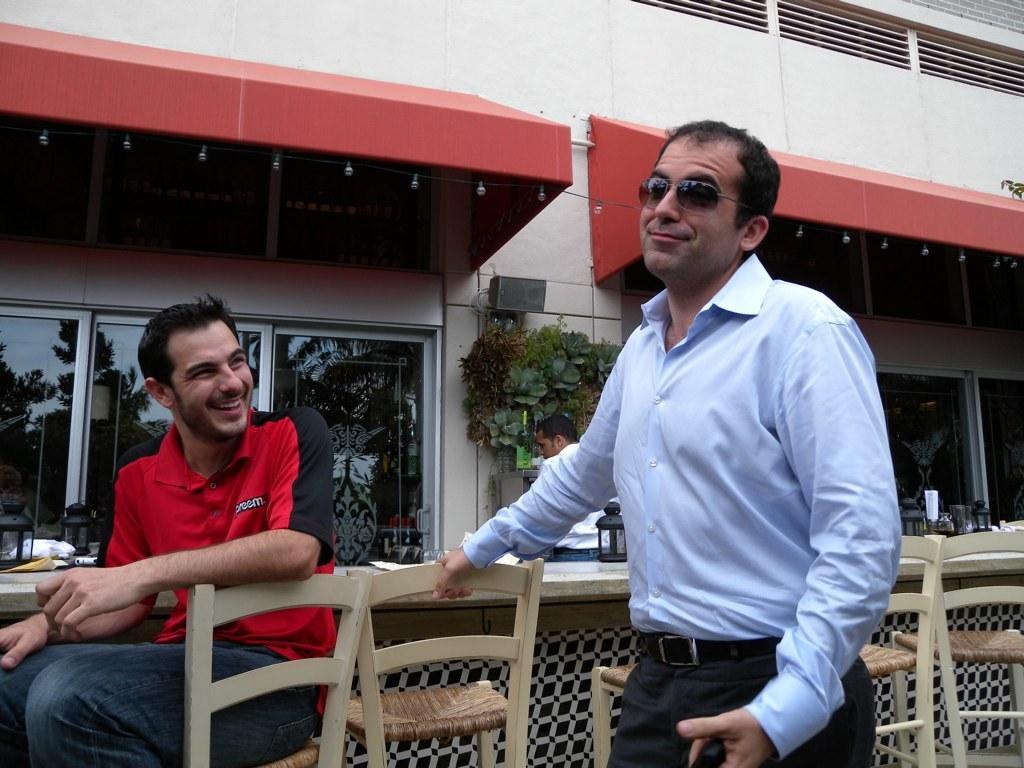How would you summarize this image in a sentence or two? It is an open area, there is a table there are three persons in the picture one person is sitting on the chair and two people are standing , in the background there is a building, some plants , a speaker and few windows. 